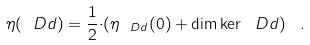Convert formula to latex. <formula><loc_0><loc_0><loc_500><loc_500>\eta ( \ D d ) = \frac { 1 } { 2 } { \cdot } ( \eta _ { \ D d } ( 0 ) + \dim \ker \ D d ) \ \, .</formula> 